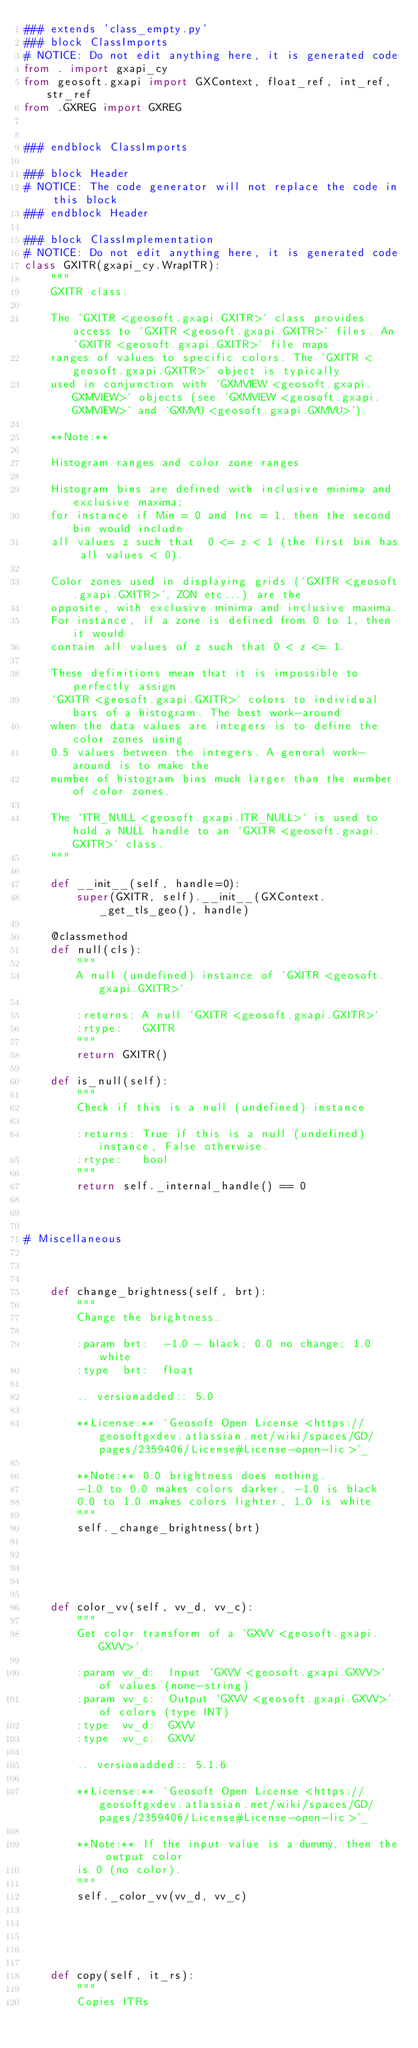Convert code to text. <code><loc_0><loc_0><loc_500><loc_500><_Python_>### extends 'class_empty.py'
### block ClassImports
# NOTICE: Do not edit anything here, it is generated code
from . import gxapi_cy
from geosoft.gxapi import GXContext, float_ref, int_ref, str_ref
from .GXREG import GXREG


### endblock ClassImports

### block Header
# NOTICE: The code generator will not replace the code in this block
### endblock Header

### block ClassImplementation
# NOTICE: Do not edit anything here, it is generated code
class GXITR(gxapi_cy.WrapITR):
    """
    GXITR class.

    The `GXITR <geosoft.gxapi.GXITR>` class provides access to `GXITR <geosoft.gxapi.GXITR>` files. An `GXITR <geosoft.gxapi.GXITR>` file maps
    ranges of values to specific colors. The `GXITR <geosoft.gxapi.GXITR>` object is typically
    used in conjunction with `GXMVIEW <geosoft.gxapi.GXMVIEW>` objects (see `GXMVIEW <geosoft.gxapi.GXMVIEW>` and `GXMVU <geosoft.gxapi.GXMVU>`).

    **Note:**

    Histogram ranges and color zone ranges

    Histogram bins are defined with inclusive minima and exclusive maxima;
    for instance if Min = 0 and Inc = 1, then the second bin would include
    all values z such that  0 <= z < 1 (the first bin has all values < 0).

    Color zones used in displaying grids (`GXITR <geosoft.gxapi.GXITR>`, ZON etc...) are the
    opposite, with exclusive minima and inclusive maxima.
    For instance, if a zone is defined from 0 to 1, then it would
    contain all values of z such that 0 < z <= 1.

    These definitions mean that it is impossible to perfectly assign
    `GXITR <geosoft.gxapi.GXITR>` colors to individual bars of a histogram. The best work-around
    when the data values are integers is to define the color zones using
    0.5 values between the integers. A general work-around is to make the
    number of histogram bins much larger than the number of color zones.

    The `ITR_NULL <geosoft.gxapi.ITR_NULL>` is used to hold a NULL handle to an `GXITR <geosoft.gxapi.GXITR>` class.
    """

    def __init__(self, handle=0):
        super(GXITR, self).__init__(GXContext._get_tls_geo(), handle)

    @classmethod
    def null(cls):
        """
        A null (undefined) instance of `GXITR <geosoft.gxapi.GXITR>`
        
        :returns: A null `GXITR <geosoft.gxapi.GXITR>`
        :rtype:   GXITR
        """
        return GXITR()

    def is_null(self):
        """
        Check if this is a null (undefined) instance
        
        :returns: True if this is a null (undefined) instance, False otherwise.
        :rtype:   bool
        """
        return self._internal_handle() == 0



# Miscellaneous



    def change_brightness(self, brt):
        """
        Change the brightness.
        
        :param brt:  -1.0 - black; 0.0 no change; 1.0 white
        :type  brt:  float

        .. versionadded:: 5.0

        **License:** `Geosoft Open License <https://geosoftgxdev.atlassian.net/wiki/spaces/GD/pages/2359406/License#License-open-lic>`_

        **Note:** 0.0 brightness does nothing.
        -1.0 to 0.0 makes colors darker, -1.0 is black
        0.0 to 1.0 makes colors lighter, 1.0 is white
        """
        self._change_brightness(brt)
        




    def color_vv(self, vv_d, vv_c):
        """
        Get color transform of a `GXVV <geosoft.gxapi.GXVV>`.
        
        :param vv_d:  Input `GXVV <geosoft.gxapi.GXVV>` of values (none-string)
        :param vv_c:  Output `GXVV <geosoft.gxapi.GXVV>` of colors (type INT)
        :type  vv_d:  GXVV
        :type  vv_c:  GXVV

        .. versionadded:: 5.1.6

        **License:** `Geosoft Open License <https://geosoftgxdev.atlassian.net/wiki/spaces/GD/pages/2359406/License#License-open-lic>`_

        **Note:** If the input value is a dummy, then the output color
        is 0 (no color).
        """
        self._color_vv(vv_d, vv_c)
        




    def copy(self, it_rs):
        """
        Copies ITRs
        </code> 